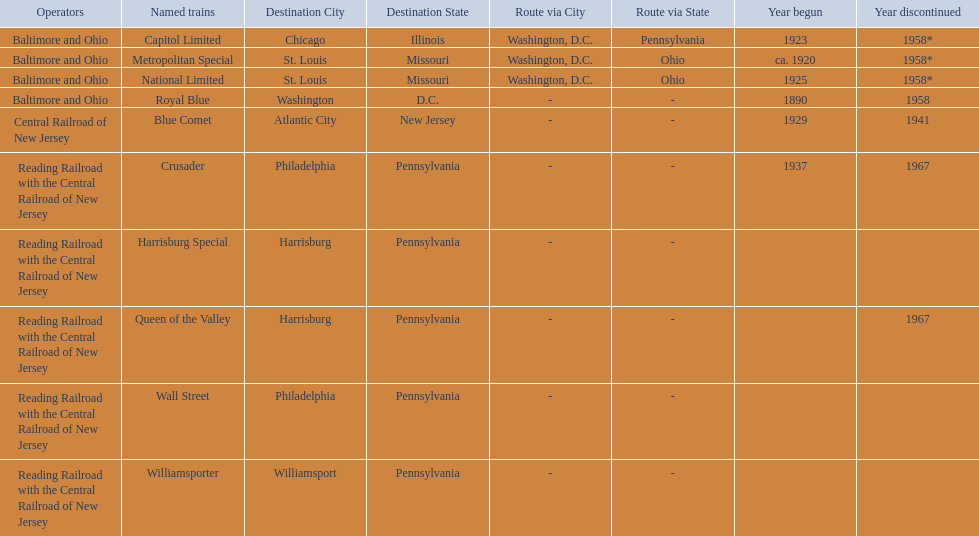What are the destinations of the central railroad of new jersey terminal? Chicago, Illinois via Washington, D.C. and Pittsburgh, Pennsylvania, St. Louis, Missouri via Washington, D.C. and Cincinnati, Ohio, St. Louis, Missouri via Washington, D.C. and Cincinnati, Ohio, Washington, D.C., Atlantic City, New Jersey, Philadelphia, Pennsylvania, Harrisburg, Pennsylvania, Harrisburg, Pennsylvania, Philadelphia, Pennsylvania, Williamsport, Pennsylvania. Which of these destinations is at the top of the list? Chicago, Illinois via Washington, D.C. and Pittsburgh, Pennsylvania. 